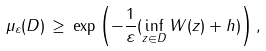<formula> <loc_0><loc_0><loc_500><loc_500>\mu _ { \varepsilon } ( D ) \, \geq \, \exp { \left ( - \frac { 1 } { \varepsilon } ( \inf _ { z \in D } W ( z ) + h ) \right ) } \, ,</formula> 